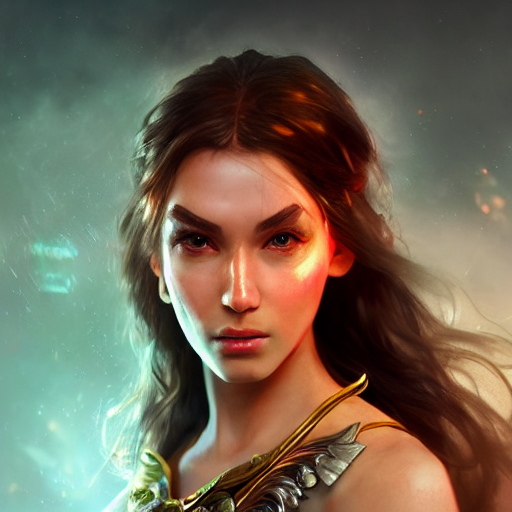What emotions does the character's expression convey? The character's expression conveys a mix of determination and pensiveness, with a hint of underlying strength and resilience ready to be unleashed. What's the story behind the character's armor? The ornate design of the armor suggests a status of high honor, likely indicating a warrior of significant prowess, possibly with a background filled with heroic deeds and battles. 